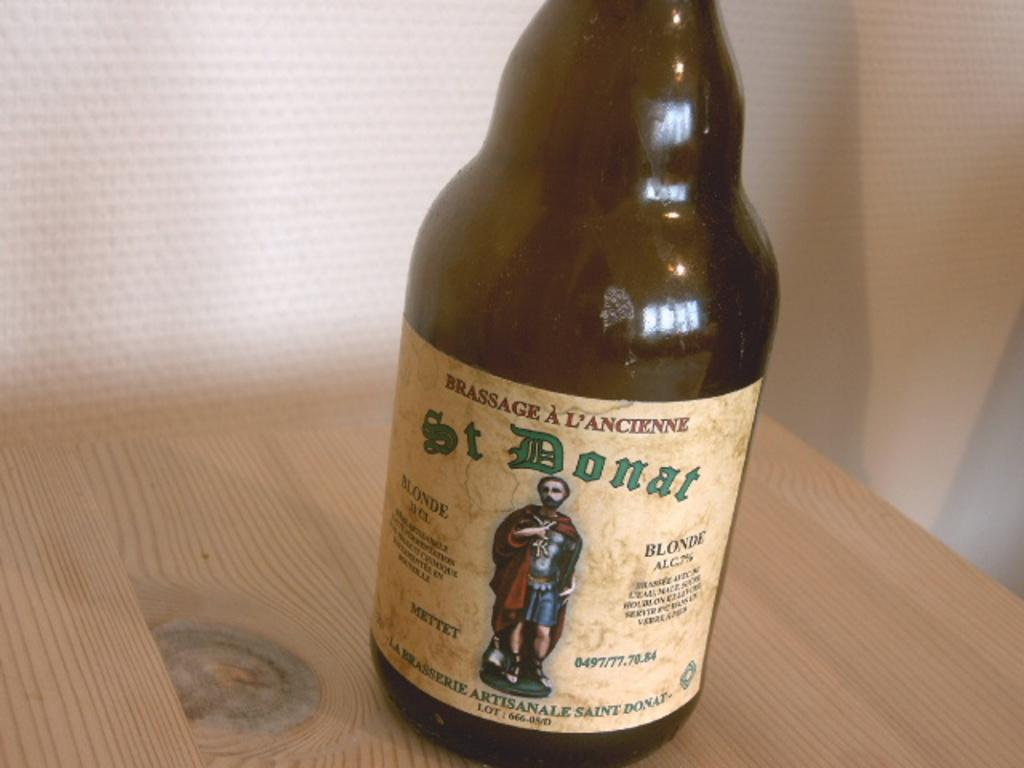<image>
Create a compact narrative representing the image presented. A St Donat bottle is on a wood table. 